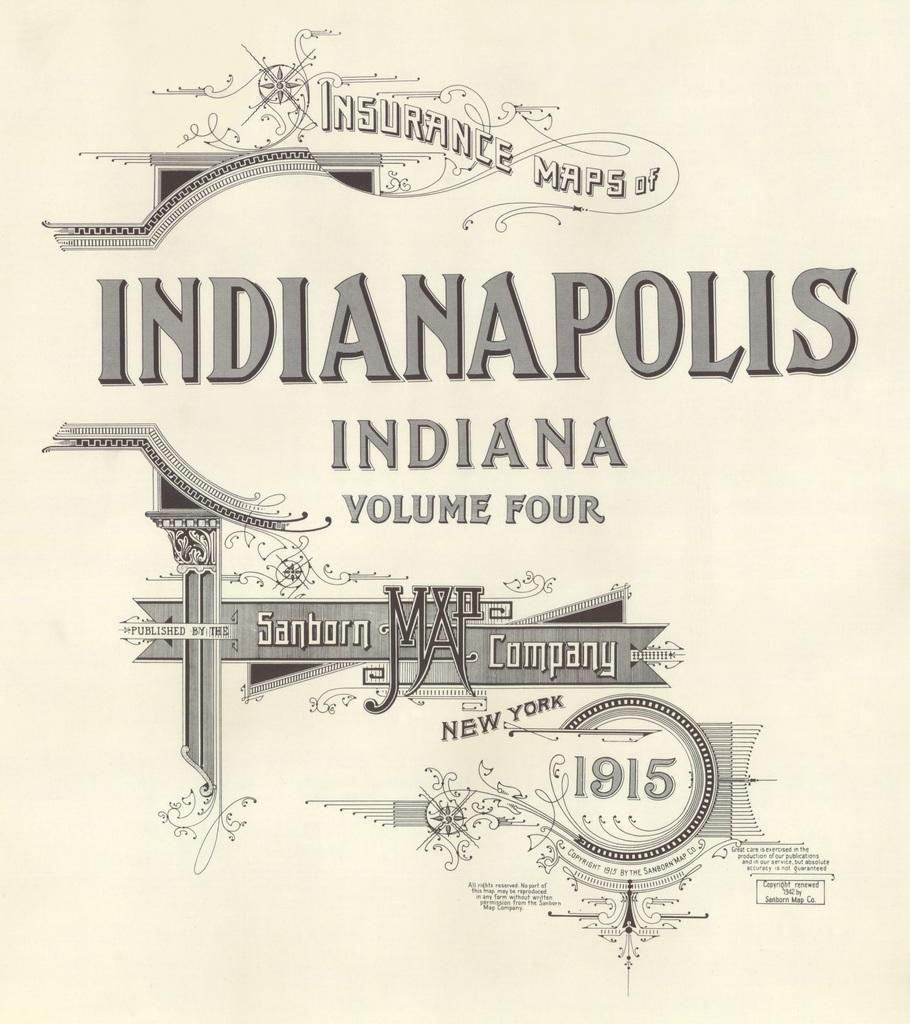<image>
Present a compact description of the photo's key features. A book of Insurance Maps of Indianapolis Indiana is the fourth volume. 